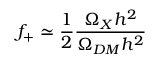Convert formula to latex. <formula><loc_0><loc_0><loc_500><loc_500>f _ { + } \simeq \frac { 1 } { 2 } \frac { \Omega _ { X } h ^ { 2 } } { \Omega _ { D M } h ^ { 2 } }</formula> 